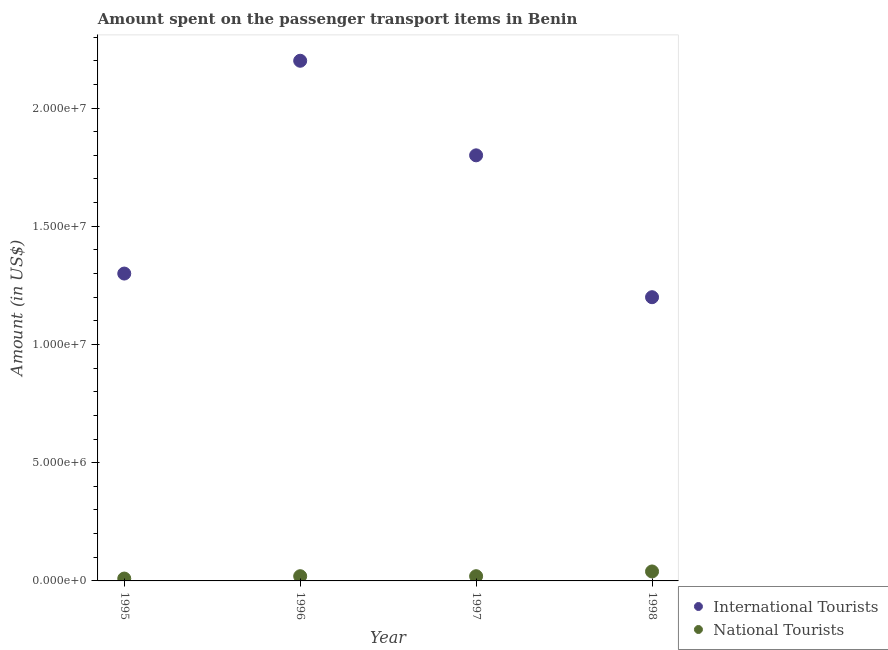What is the amount spent on transport items of national tourists in 1997?
Provide a short and direct response. 2.00e+05. Across all years, what is the maximum amount spent on transport items of international tourists?
Offer a terse response. 2.20e+07. Across all years, what is the minimum amount spent on transport items of international tourists?
Your answer should be very brief. 1.20e+07. In which year was the amount spent on transport items of international tourists maximum?
Provide a short and direct response. 1996. What is the total amount spent on transport items of international tourists in the graph?
Keep it short and to the point. 6.50e+07. What is the difference between the amount spent on transport items of national tourists in 1996 and that in 1998?
Provide a succinct answer. -2.00e+05. What is the difference between the amount spent on transport items of national tourists in 1996 and the amount spent on transport items of international tourists in 1995?
Provide a succinct answer. -1.28e+07. What is the average amount spent on transport items of national tourists per year?
Ensure brevity in your answer.  2.25e+05. In the year 1997, what is the difference between the amount spent on transport items of international tourists and amount spent on transport items of national tourists?
Make the answer very short. 1.78e+07. In how many years, is the amount spent on transport items of international tourists greater than 4000000 US$?
Your answer should be very brief. 4. What is the ratio of the amount spent on transport items of international tourists in 1997 to that in 1998?
Keep it short and to the point. 1.5. Is the difference between the amount spent on transport items of national tourists in 1996 and 1997 greater than the difference between the amount spent on transport items of international tourists in 1996 and 1997?
Keep it short and to the point. No. What is the difference between the highest and the second highest amount spent on transport items of national tourists?
Make the answer very short. 2.00e+05. What is the difference between the highest and the lowest amount spent on transport items of national tourists?
Keep it short and to the point. 3.00e+05. Does the amount spent on transport items of national tourists monotonically increase over the years?
Your answer should be compact. No. Is the amount spent on transport items of international tourists strictly greater than the amount spent on transport items of national tourists over the years?
Offer a terse response. Yes. How many dotlines are there?
Provide a short and direct response. 2. How many years are there in the graph?
Make the answer very short. 4. What is the difference between two consecutive major ticks on the Y-axis?
Keep it short and to the point. 5.00e+06. Does the graph contain any zero values?
Keep it short and to the point. No. Where does the legend appear in the graph?
Provide a short and direct response. Bottom right. What is the title of the graph?
Offer a very short reply. Amount spent on the passenger transport items in Benin. What is the label or title of the Y-axis?
Your answer should be compact. Amount (in US$). What is the Amount (in US$) in International Tourists in 1995?
Ensure brevity in your answer.  1.30e+07. What is the Amount (in US$) of National Tourists in 1995?
Your response must be concise. 1.00e+05. What is the Amount (in US$) in International Tourists in 1996?
Provide a short and direct response. 2.20e+07. What is the Amount (in US$) of National Tourists in 1996?
Your answer should be very brief. 2.00e+05. What is the Amount (in US$) of International Tourists in 1997?
Offer a terse response. 1.80e+07. What is the Amount (in US$) of International Tourists in 1998?
Provide a succinct answer. 1.20e+07. What is the Amount (in US$) of National Tourists in 1998?
Provide a short and direct response. 4.00e+05. Across all years, what is the maximum Amount (in US$) in International Tourists?
Your answer should be compact. 2.20e+07. Across all years, what is the maximum Amount (in US$) of National Tourists?
Give a very brief answer. 4.00e+05. Across all years, what is the minimum Amount (in US$) in National Tourists?
Make the answer very short. 1.00e+05. What is the total Amount (in US$) of International Tourists in the graph?
Provide a succinct answer. 6.50e+07. What is the total Amount (in US$) of National Tourists in the graph?
Ensure brevity in your answer.  9.00e+05. What is the difference between the Amount (in US$) in International Tourists in 1995 and that in 1996?
Your answer should be very brief. -9.00e+06. What is the difference between the Amount (in US$) of National Tourists in 1995 and that in 1996?
Your response must be concise. -1.00e+05. What is the difference between the Amount (in US$) of International Tourists in 1995 and that in 1997?
Provide a short and direct response. -5.00e+06. What is the difference between the Amount (in US$) of International Tourists in 1995 and that in 1998?
Your answer should be compact. 1.00e+06. What is the difference between the Amount (in US$) in International Tourists in 1996 and that in 1997?
Your answer should be compact. 4.00e+06. What is the difference between the Amount (in US$) of International Tourists in 1997 and that in 1998?
Your answer should be compact. 6.00e+06. What is the difference between the Amount (in US$) in National Tourists in 1997 and that in 1998?
Your answer should be very brief. -2.00e+05. What is the difference between the Amount (in US$) in International Tourists in 1995 and the Amount (in US$) in National Tourists in 1996?
Provide a short and direct response. 1.28e+07. What is the difference between the Amount (in US$) of International Tourists in 1995 and the Amount (in US$) of National Tourists in 1997?
Make the answer very short. 1.28e+07. What is the difference between the Amount (in US$) in International Tourists in 1995 and the Amount (in US$) in National Tourists in 1998?
Provide a succinct answer. 1.26e+07. What is the difference between the Amount (in US$) of International Tourists in 1996 and the Amount (in US$) of National Tourists in 1997?
Your answer should be compact. 2.18e+07. What is the difference between the Amount (in US$) in International Tourists in 1996 and the Amount (in US$) in National Tourists in 1998?
Make the answer very short. 2.16e+07. What is the difference between the Amount (in US$) of International Tourists in 1997 and the Amount (in US$) of National Tourists in 1998?
Provide a short and direct response. 1.76e+07. What is the average Amount (in US$) in International Tourists per year?
Provide a succinct answer. 1.62e+07. What is the average Amount (in US$) of National Tourists per year?
Make the answer very short. 2.25e+05. In the year 1995, what is the difference between the Amount (in US$) in International Tourists and Amount (in US$) in National Tourists?
Your answer should be compact. 1.29e+07. In the year 1996, what is the difference between the Amount (in US$) of International Tourists and Amount (in US$) of National Tourists?
Offer a very short reply. 2.18e+07. In the year 1997, what is the difference between the Amount (in US$) of International Tourists and Amount (in US$) of National Tourists?
Provide a succinct answer. 1.78e+07. In the year 1998, what is the difference between the Amount (in US$) of International Tourists and Amount (in US$) of National Tourists?
Provide a succinct answer. 1.16e+07. What is the ratio of the Amount (in US$) in International Tourists in 1995 to that in 1996?
Offer a very short reply. 0.59. What is the ratio of the Amount (in US$) of National Tourists in 1995 to that in 1996?
Offer a very short reply. 0.5. What is the ratio of the Amount (in US$) of International Tourists in 1995 to that in 1997?
Keep it short and to the point. 0.72. What is the ratio of the Amount (in US$) of International Tourists in 1995 to that in 1998?
Keep it short and to the point. 1.08. What is the ratio of the Amount (in US$) of National Tourists in 1995 to that in 1998?
Ensure brevity in your answer.  0.25. What is the ratio of the Amount (in US$) of International Tourists in 1996 to that in 1997?
Give a very brief answer. 1.22. What is the ratio of the Amount (in US$) in International Tourists in 1996 to that in 1998?
Offer a terse response. 1.83. What is the ratio of the Amount (in US$) in International Tourists in 1997 to that in 1998?
Ensure brevity in your answer.  1.5. What is the difference between the highest and the second highest Amount (in US$) in National Tourists?
Give a very brief answer. 2.00e+05. 